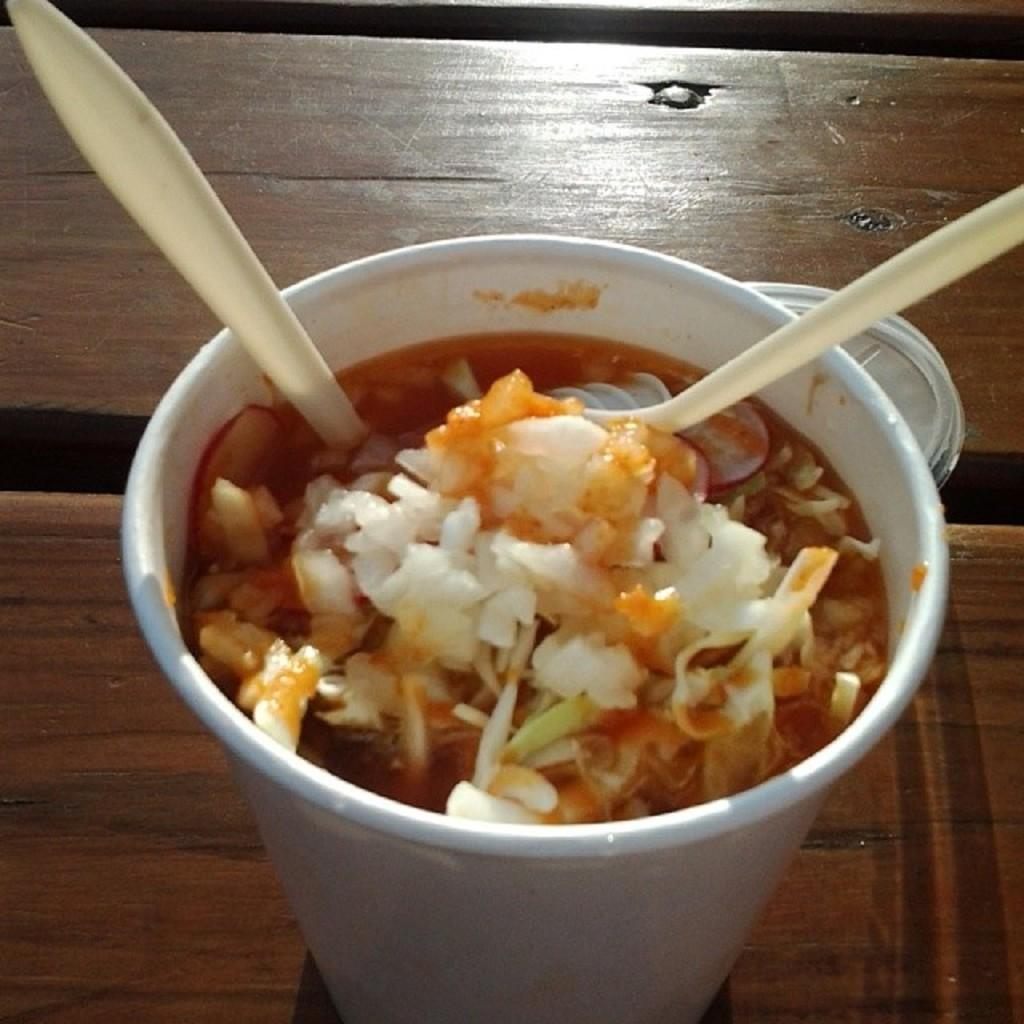What type of food item is in the cup in the image? The specific type of food item in the cup is not mentioned, but it is a food item. How many spoons are visible in the image? There are two spoons in the image. What object is on the table in the image? There is a lid on the table in the image. What is the business of the person holding the cup in the image? There is no person holding the cup in the image, so it is not possible to determine their business. 